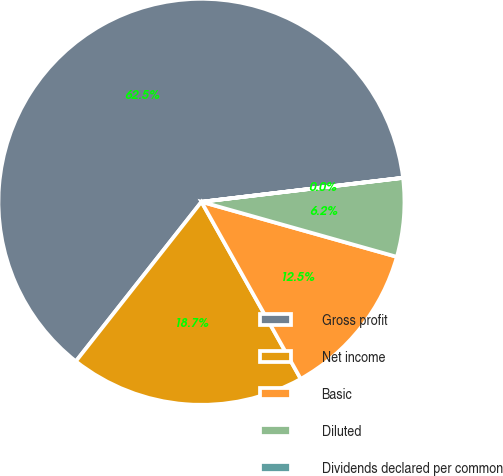Convert chart to OTSL. <chart><loc_0><loc_0><loc_500><loc_500><pie_chart><fcel>Gross profit<fcel>Net income<fcel>Basic<fcel>Diluted<fcel>Dividends declared per common<nl><fcel>62.49%<fcel>18.75%<fcel>12.5%<fcel>6.25%<fcel>0.01%<nl></chart> 